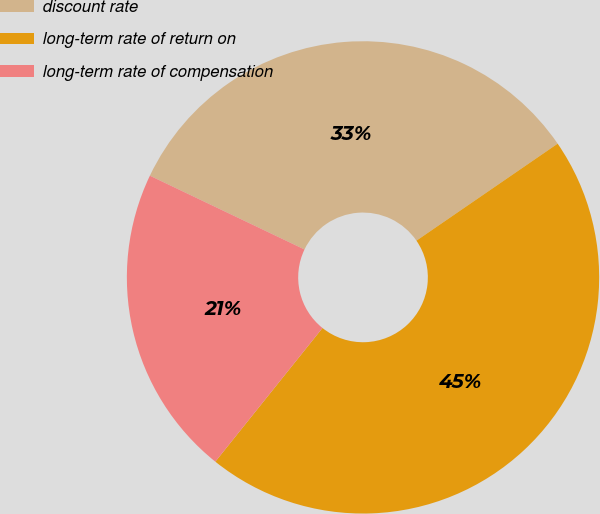<chart> <loc_0><loc_0><loc_500><loc_500><pie_chart><fcel>discount rate<fcel>long-term rate of return on<fcel>long-term rate of compensation<nl><fcel>33.33%<fcel>45.33%<fcel>21.33%<nl></chart> 